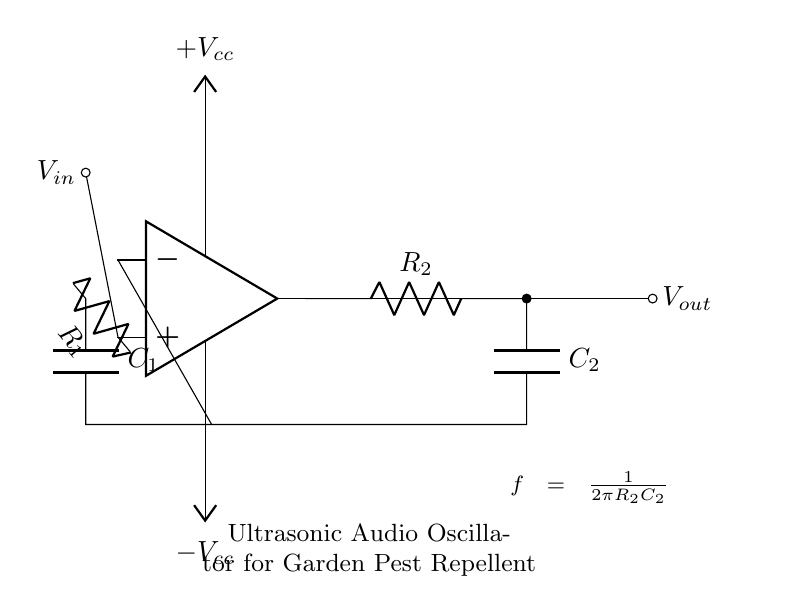What type of oscillator is this circuit? The circuit is an audio oscillator, as indicated by its design and purpose for generating ultrasonic frequencies.
Answer: audio oscillator Which components are used in the feedback network? The feedback network consists of a resistor labeled R2 and a capacitor labeled C2. This connectivity helps create the oscillation needed for the circuit.
Answer: R2, C2 What does the frequency equation indicate about the relationship between components? The frequency equation shows that the frequency is inversely related to the product of the resistor R2 and capacitor C2 values, meaning increasing either will reduce the frequency.
Answer: Inverse relationship What is the output voltage notation in the circuit? The output voltage is denoted as V out, signifying the voltage produced by the oscillator circuit. The label is placed at the output terminal of the op-amp.
Answer: V out What is the general purpose of this ultrasonic audio oscillator? This oscillator is designed to generate ultrasonic frequencies that can repel garden pests, serving as a pest deterrent.
Answer: Repel garden pests Where is the power supply connected in the circuit? The power supply is connected to the op-amp with positive voltage labeled +Vcc and negative voltage labeled -Vcc, ensuring the op-amp operates effectively.
Answer: Op-amp 